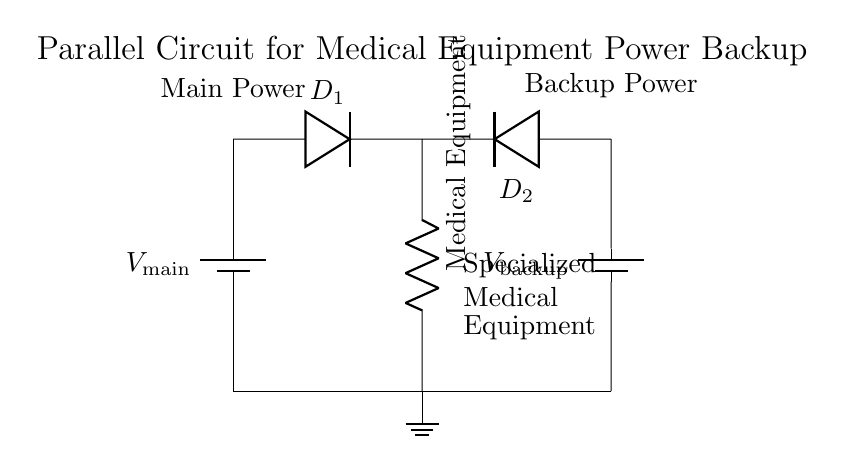What is the main power source in the circuit? The main power source is labeled as V_main and is represented by the first battery located on the left side of the diagram.
Answer: V_main How many diodes are present in this circuit? There are two diodes shown in the circuit, labeled D_1 and D_2, one connected from each power source to the load.
Answer: 2 What type of circuit is depicted in the diagram? The diagram illustrates a parallel circuit configuration, where multiple power sources supply power to a single load simultaneously.
Answer: Parallel What is the role of the diodes in the circuit? The diodes, D_1 and D_2, allow current to flow from either the main power source or the backup power source while preventing backflow, ensuring reliable operation of the load.
Answer: Prevent backflow What happens if the main power fails? If the main power fails, the backup power source (V_backup) provides power through diode D_2 to keep the medical equipment operational.
Answer: Back-up power Where is the medical equipment located in the circuit? The medical equipment is represented as a resistor labeled just below the diodes, indicating it as the load in the circuit.
Answer: Below the diodes 